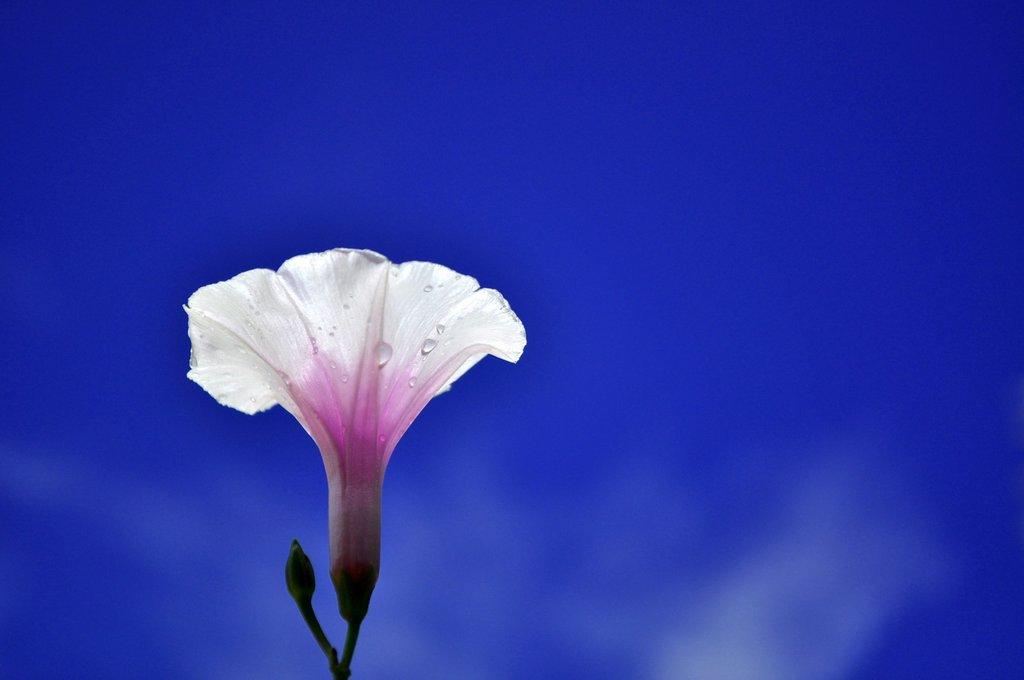What type of object is present in the image? There is a flower in the image. Can you describe the color of the flower? The flower has a white and pink color. What stage of growth is the flower in? There is a flower bud in the image, indicating that it is in an early stage of growth. What color is the background of the image? The background of the image is blue. What type of record is being discussed in the image? There is no record or discussion present in the image; it features a flower with a white and pink color, a flower bud, and a blue background. 